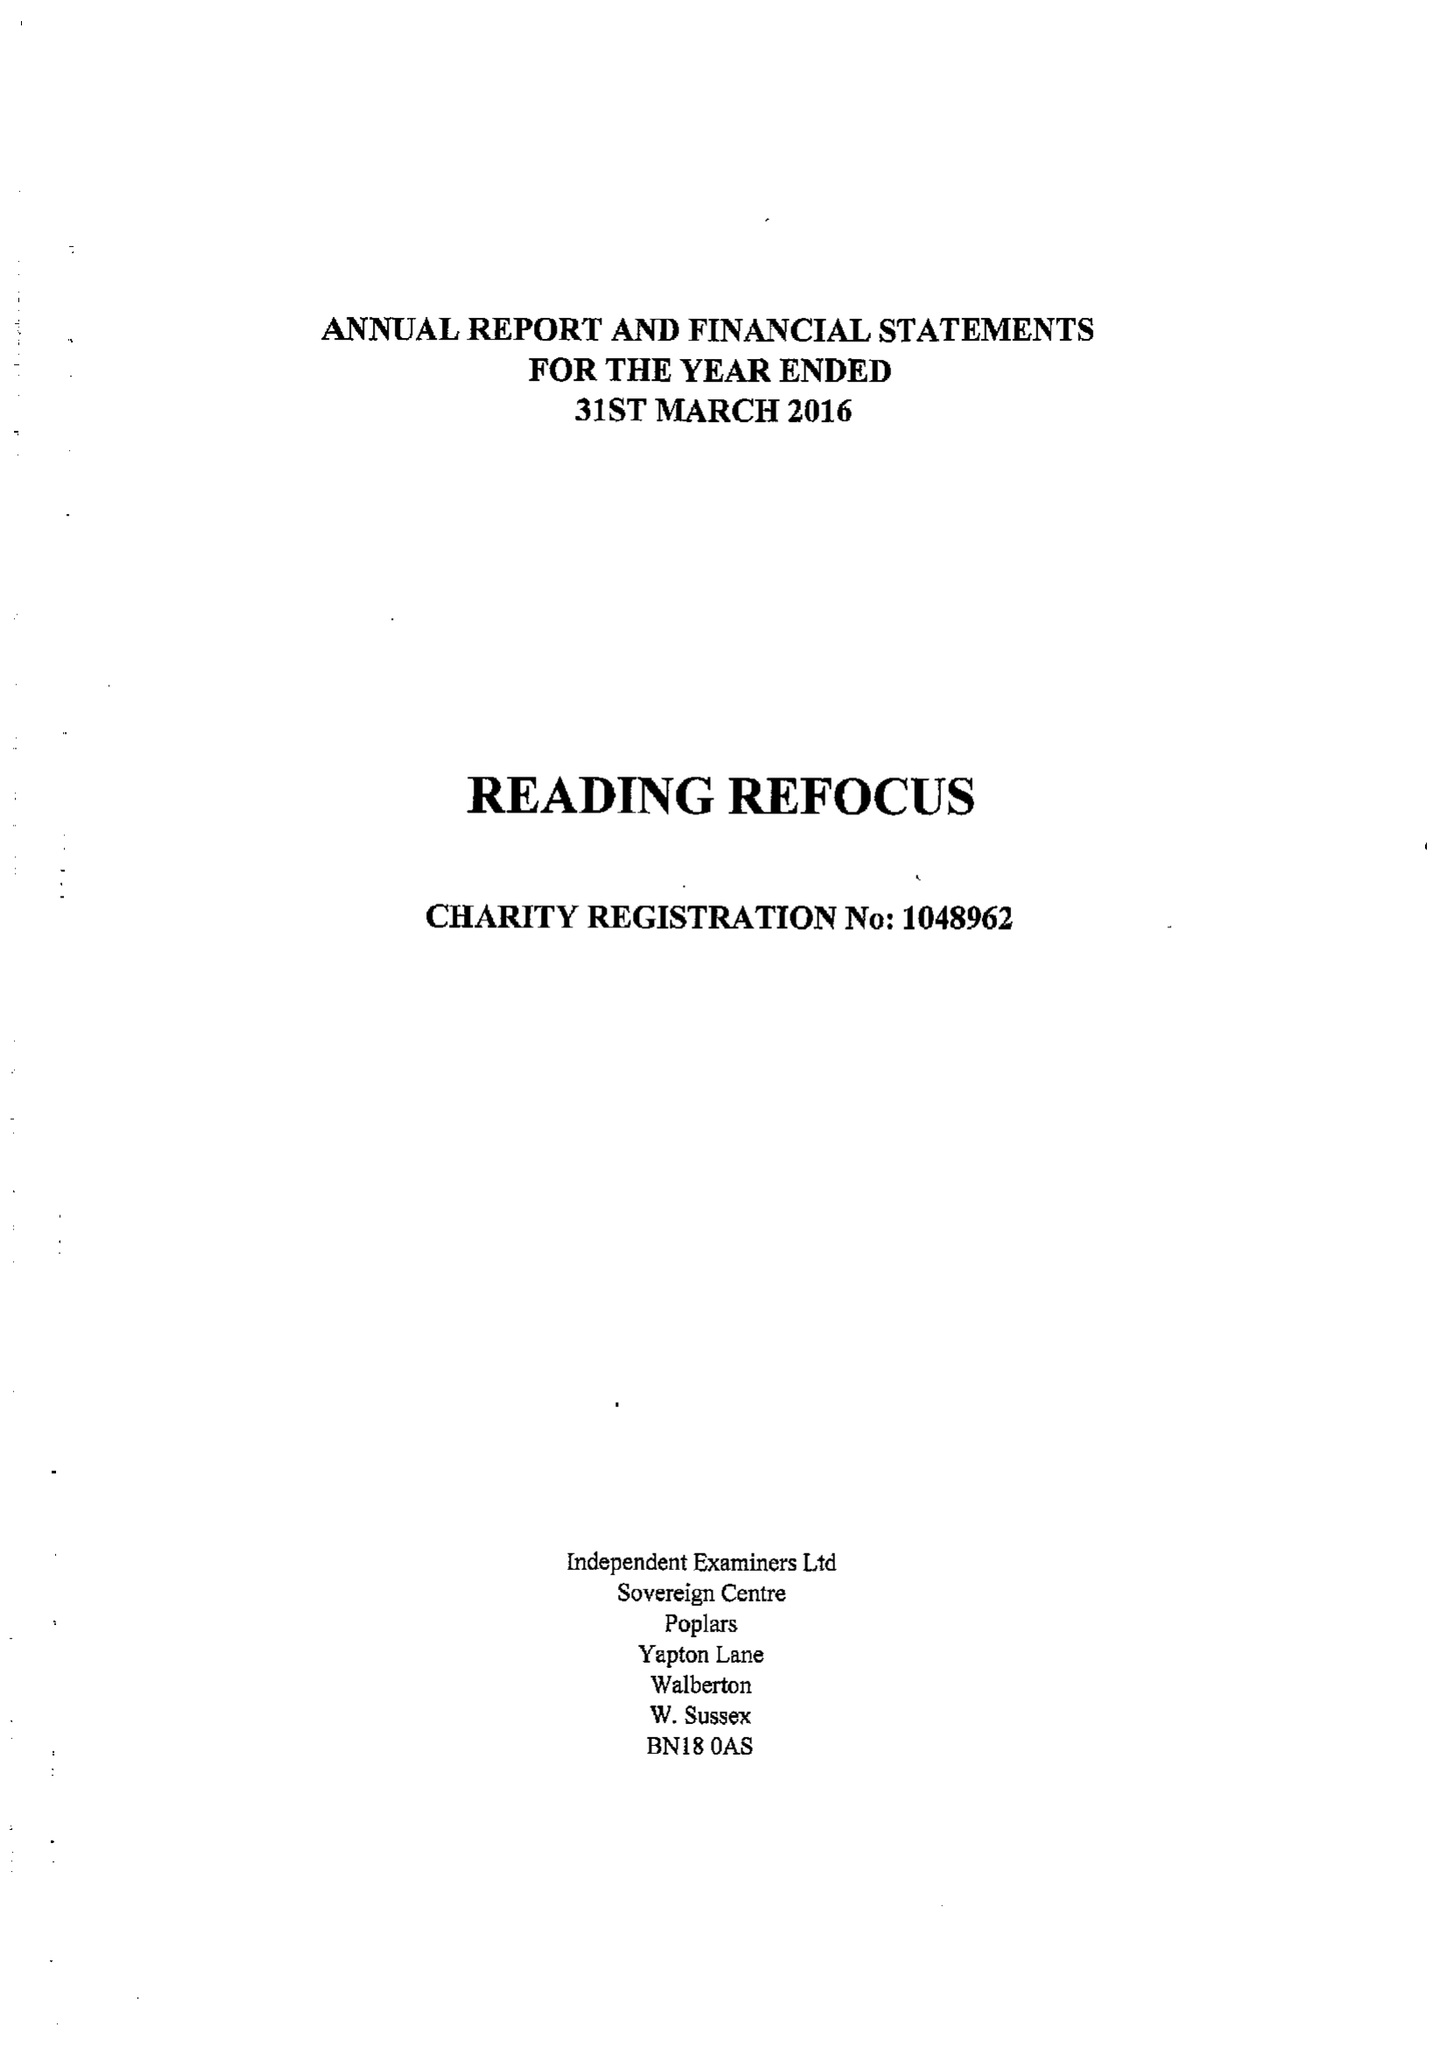What is the value for the charity_name?
Answer the question using a single word or phrase. Reading Refocus 